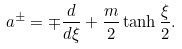<formula> <loc_0><loc_0><loc_500><loc_500>a ^ { \pm } = \mp \frac { d } { d \xi } + \frac { m } { 2 } \tanh \frac { \xi } { 2 } .</formula> 